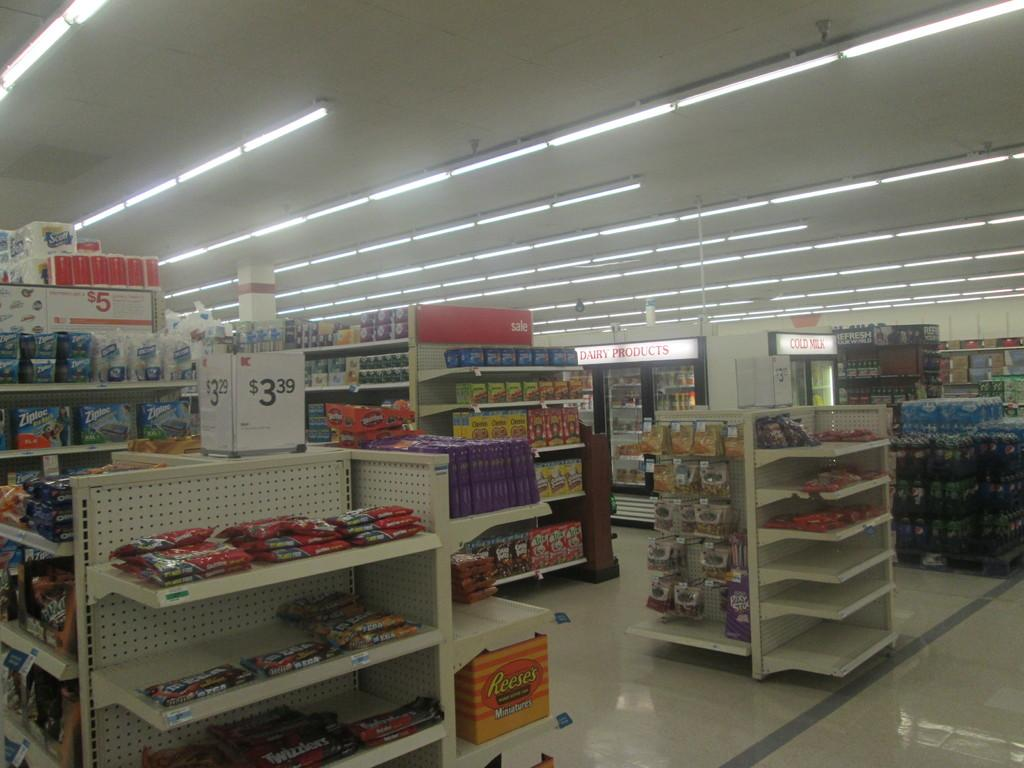<image>
Offer a succinct explanation of the picture presented. Aisles in a grocery store with candy products from reese's 